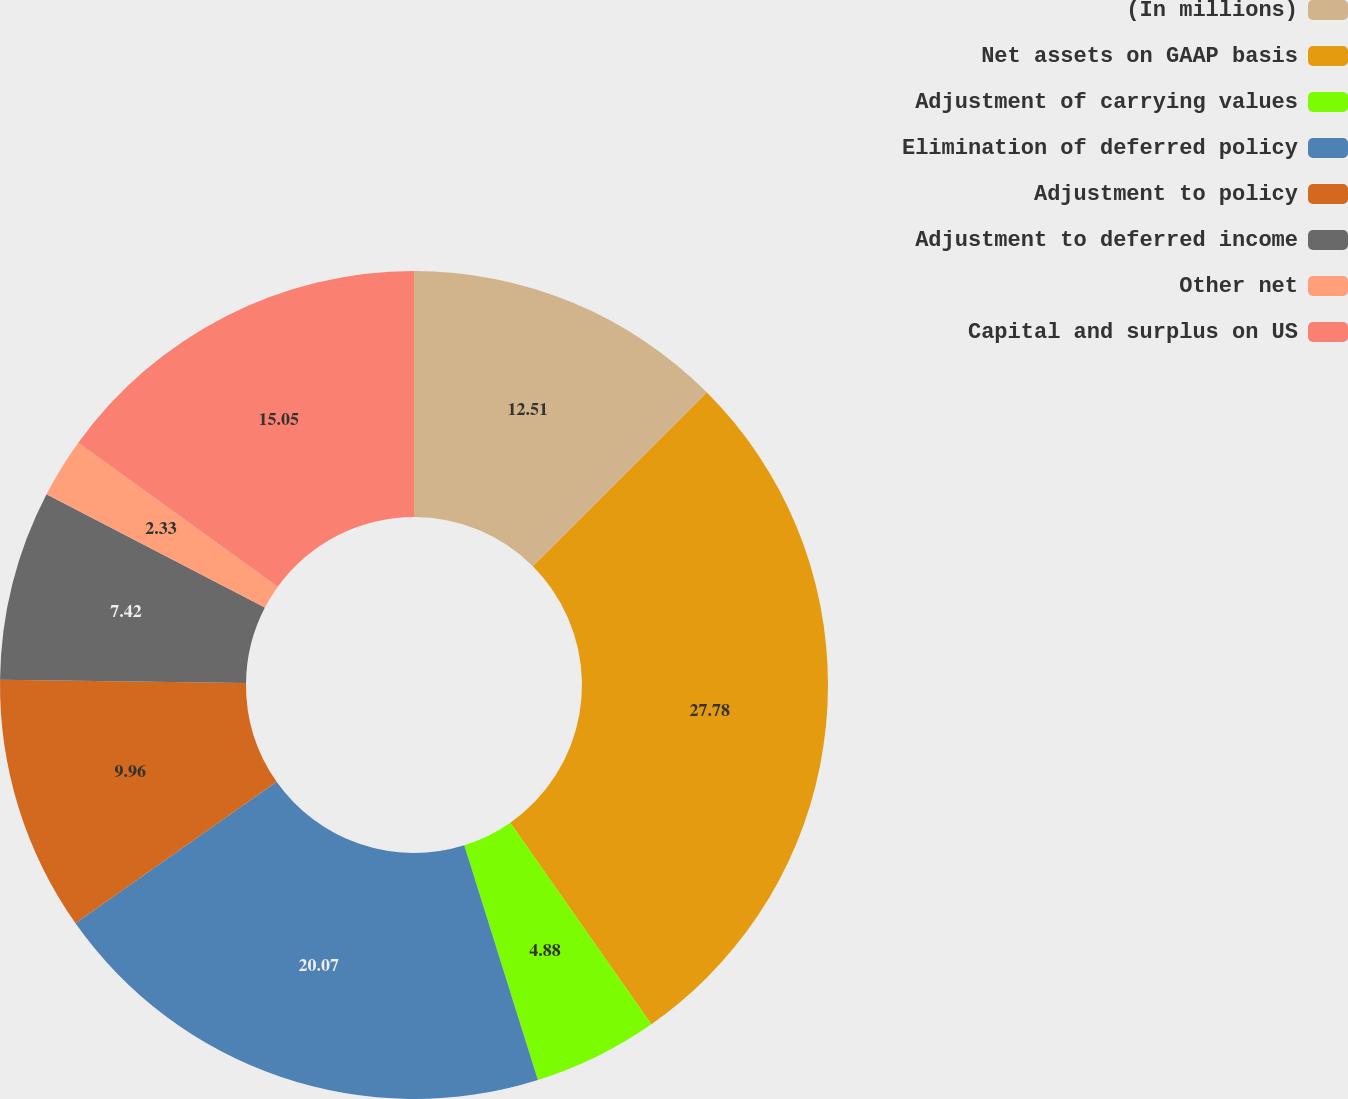<chart> <loc_0><loc_0><loc_500><loc_500><pie_chart><fcel>(In millions)<fcel>Net assets on GAAP basis<fcel>Adjustment of carrying values<fcel>Elimination of deferred policy<fcel>Adjustment to policy<fcel>Adjustment to deferred income<fcel>Other net<fcel>Capital and surplus on US<nl><fcel>12.51%<fcel>27.77%<fcel>4.88%<fcel>20.07%<fcel>9.96%<fcel>7.42%<fcel>2.33%<fcel>15.05%<nl></chart> 